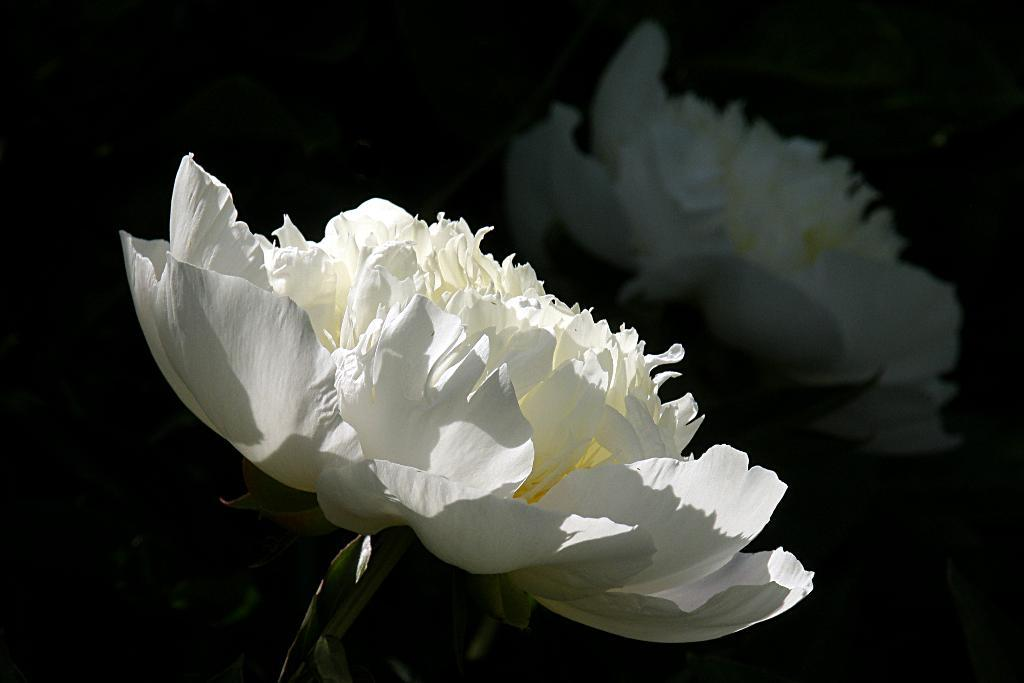What type of flower is in the image? There is a white flower in the image. Can you describe any additional features of the flower? The flower's reflection is visible on a glass surface. What advice does the grandmother give about rubbing the tramp in the image? There is no grandmother, rubbing, or tramp present in the image. 